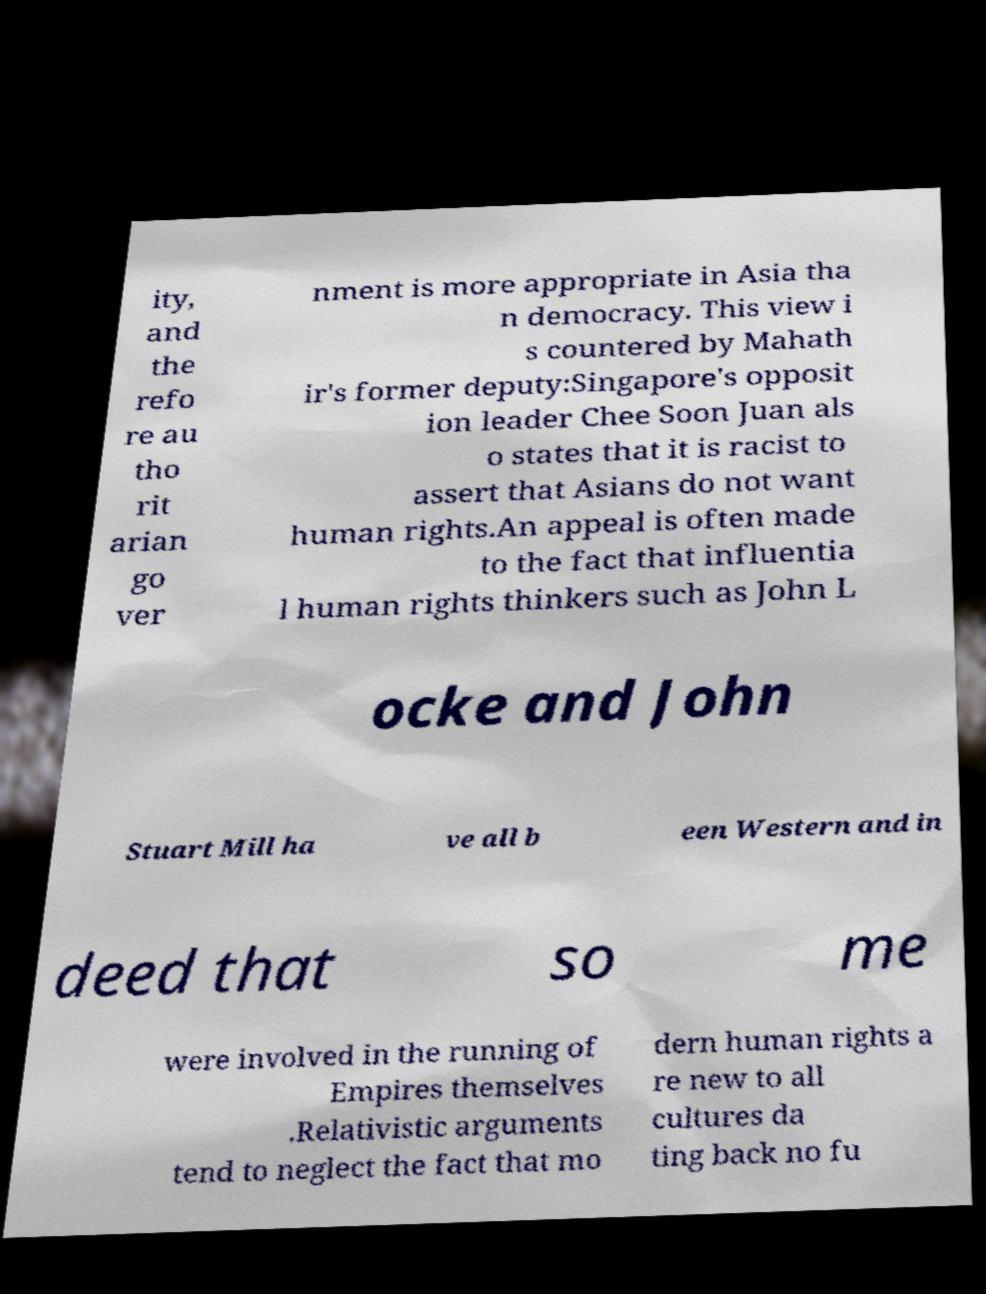Can you read and provide the text displayed in the image?This photo seems to have some interesting text. Can you extract and type it out for me? ity, and the refo re au tho rit arian go ver nment is more appropriate in Asia tha n democracy. This view i s countered by Mahath ir's former deputy:Singapore's opposit ion leader Chee Soon Juan als o states that it is racist to assert that Asians do not want human rights.An appeal is often made to the fact that influentia l human rights thinkers such as John L ocke and John Stuart Mill ha ve all b een Western and in deed that so me were involved in the running of Empires themselves .Relativistic arguments tend to neglect the fact that mo dern human rights a re new to all cultures da ting back no fu 